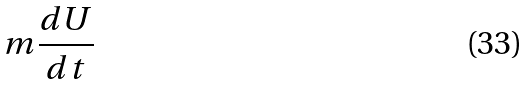<formula> <loc_0><loc_0><loc_500><loc_500>m \frac { d U } { d t }</formula> 